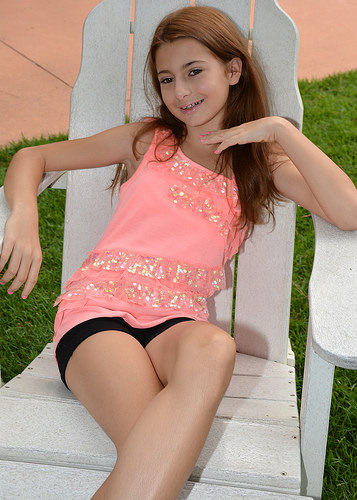<image>
Is the girl behind the chair? No. The girl is not behind the chair. From this viewpoint, the girl appears to be positioned elsewhere in the scene. 